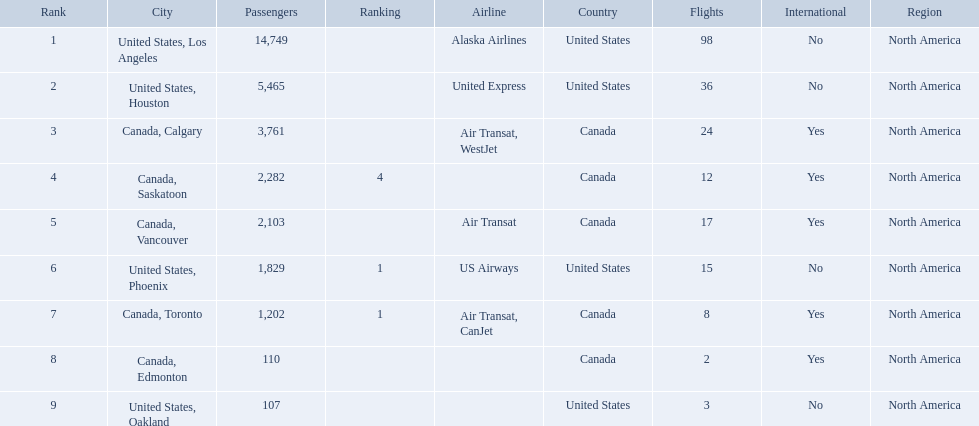Which airport has the least amount of passengers? 107. What airport has 107 passengers? United States, Oakland. Would you mind parsing the complete table? {'header': ['Rank', 'City', 'Passengers', 'Ranking', 'Airline', 'Country', 'Flights', 'International', 'Region'], 'rows': [['1', 'United States, Los Angeles', '14,749', '', 'Alaska Airlines', 'United States', '98', 'No', 'North America'], ['2', 'United States, Houston', '5,465', '', 'United Express', 'United States', '36', 'No', 'North America'], ['3', 'Canada, Calgary', '3,761', '', 'Air Transat, WestJet', 'Canada', '24', 'Yes', 'North America'], ['4', 'Canada, Saskatoon', '2,282', '4', '', 'Canada', '12', 'Yes', 'North America'], ['5', 'Canada, Vancouver', '2,103', '', 'Air Transat', 'Canada', '17', 'Yes', 'North America'], ['6', 'United States, Phoenix', '1,829', '1', 'US Airways', 'United States', '15', 'No', 'North America'], ['7', 'Canada, Toronto', '1,202', '1', 'Air Transat, CanJet', 'Canada', '8', 'Yes', 'North America'], ['8', 'Canada, Edmonton', '110', '', '', 'Canada', '2', 'Yes', 'North America'], ['9', 'United States, Oakland', '107', '', '', 'United States', '3', 'No', 'North America']]} Which cities had less than 2,000 passengers? United States, Phoenix, Canada, Toronto, Canada, Edmonton, United States, Oakland. Of these cities, which had fewer than 1,000 passengers? Canada, Edmonton, United States, Oakland. Of the cities in the previous answer, which one had only 107 passengers? United States, Oakland. What were all the passenger totals? 14,749, 5,465, 3,761, 2,282, 2,103, 1,829, 1,202, 110, 107. Which of these were to los angeles? 14,749. What other destination combined with this is closest to 19,000? Canada, Calgary. 